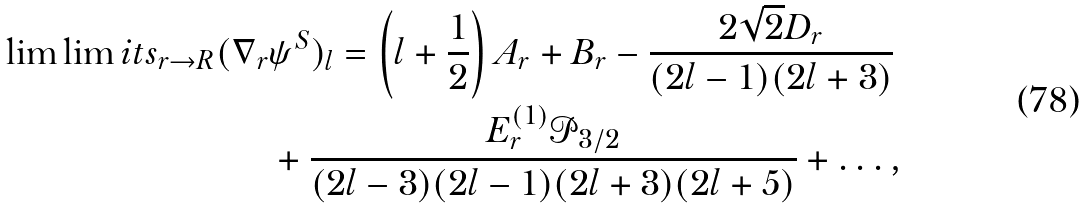Convert formula to latex. <formula><loc_0><loc_0><loc_500><loc_500>\lim \lim i t s _ { r \to R } ( \nabla _ { r } & \psi ^ { S } ) _ { l } = \left ( l + \frac { 1 } { 2 } \right ) A _ { r } + B _ { r } - \frac { 2 \sqrt { 2 } D _ { r } } { ( 2 l - 1 ) ( 2 l + 3 ) } \\ & + \frac { E ^ { ( 1 ) } _ { r } \mathcal { P } _ { 3 / 2 } } { ( 2 l - 3 ) ( 2 l - 1 ) ( 2 l + 3 ) ( 2 l + 5 ) } + \dots ,</formula> 